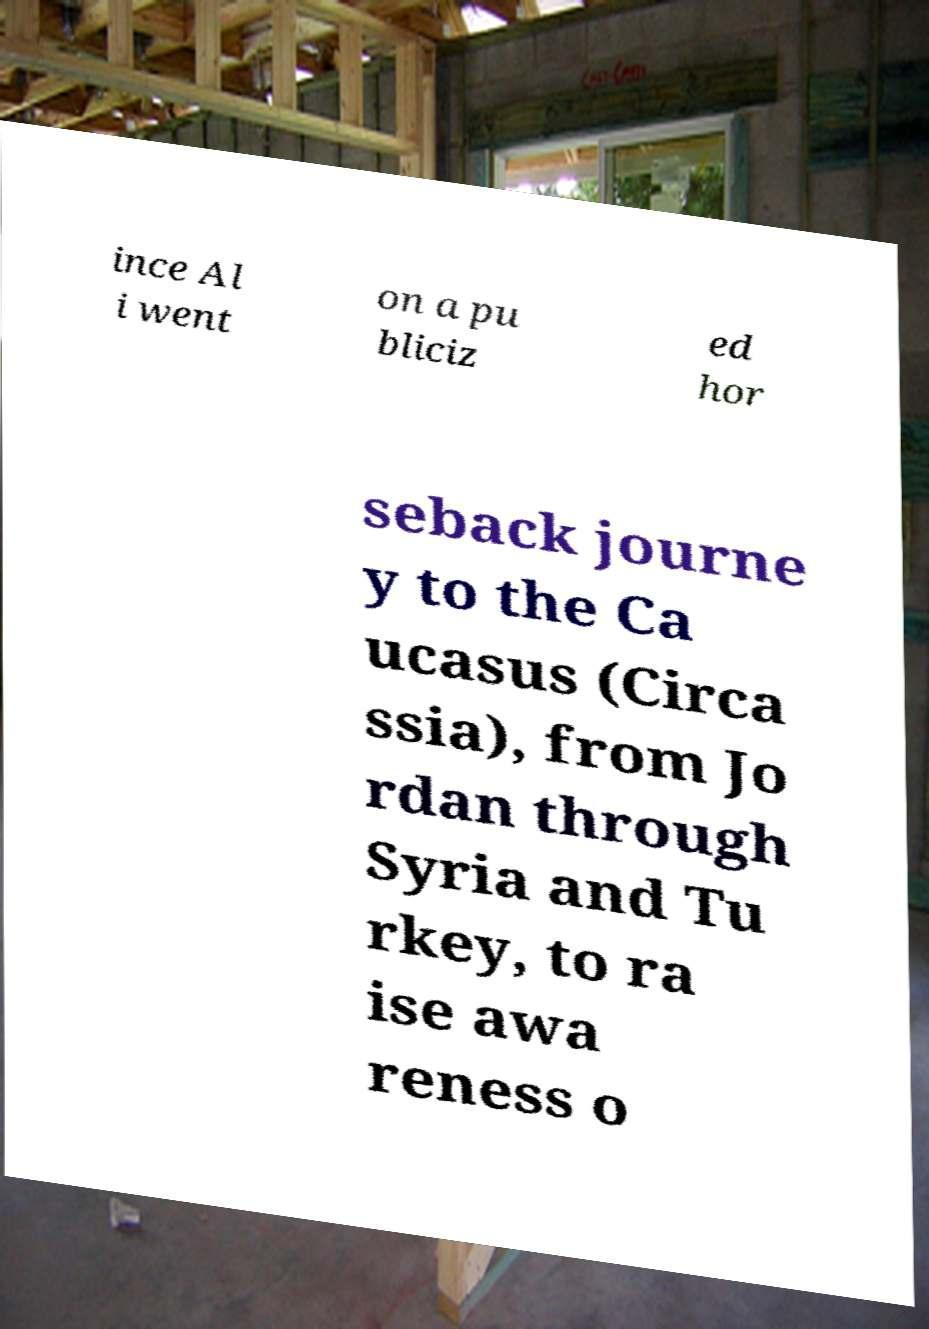Can you accurately transcribe the text from the provided image for me? ince Al i went on a pu bliciz ed hor seback journe y to the Ca ucasus (Circa ssia), from Jo rdan through Syria and Tu rkey, to ra ise awa reness o 